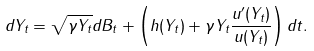<formula> <loc_0><loc_0><loc_500><loc_500>d Y _ { t } = \sqrt { \gamma Y _ { t } } d B _ { t } + \left ( h ( Y _ { t } ) + \gamma Y _ { t } \frac { u ^ { \prime } ( Y _ { t } ) } { u ( Y _ { t } ) } \right ) d t .</formula> 